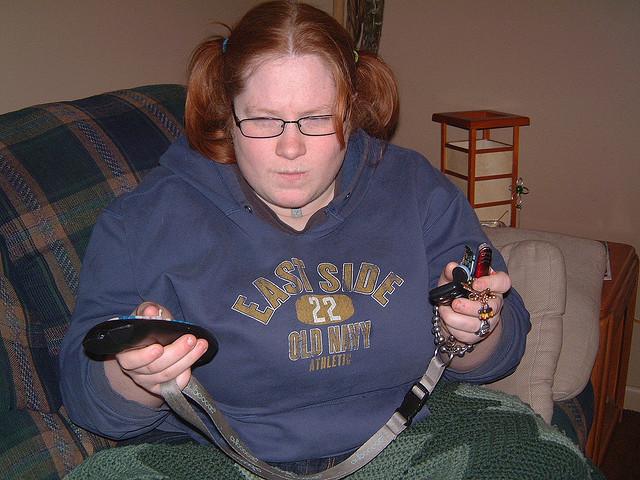What chain store is her sweatshirt from?
Quick response, please. Old navy. What is the woman sitting on?
Give a very brief answer. Couch. What color is the blanket on the woman's lap?
Be succinct. Green. 